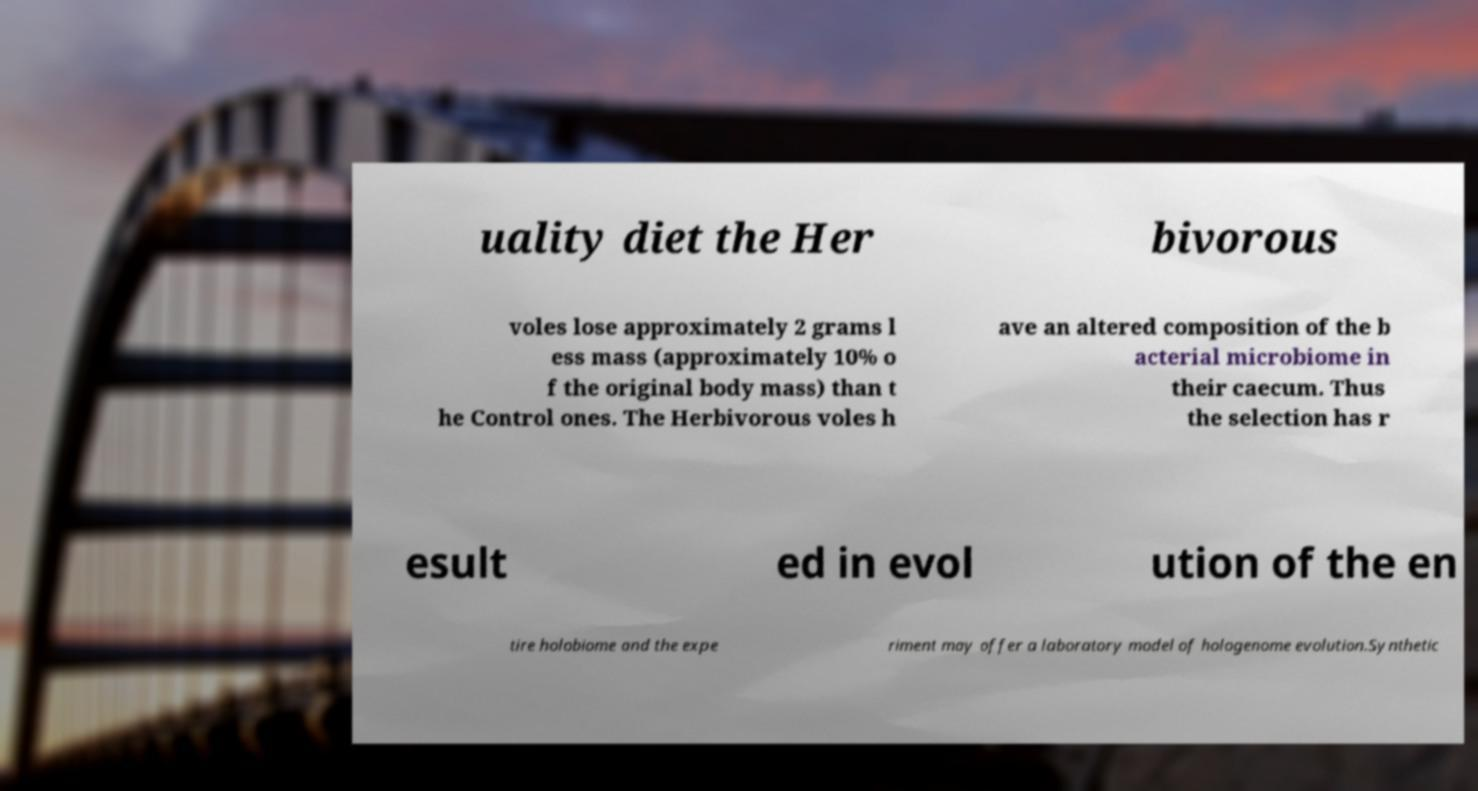Please identify and transcribe the text found in this image. uality diet the Her bivorous voles lose approximately 2 grams l ess mass (approximately 10% o f the original body mass) than t he Control ones. The Herbivorous voles h ave an altered composition of the b acterial microbiome in their caecum. Thus the selection has r esult ed in evol ution of the en tire holobiome and the expe riment may offer a laboratory model of hologenome evolution.Synthetic 